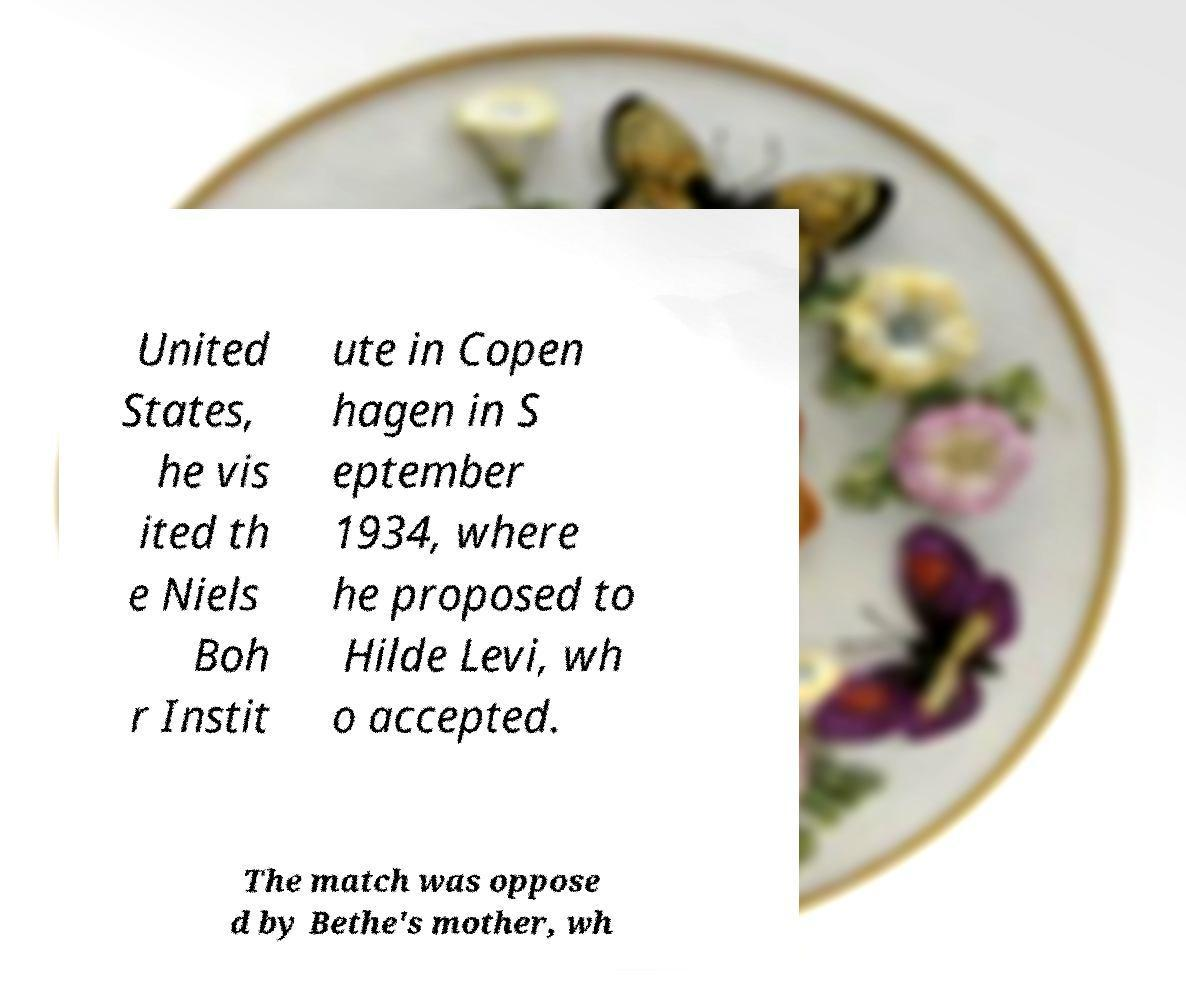Can you read and provide the text displayed in the image?This photo seems to have some interesting text. Can you extract and type it out for me? United States, he vis ited th e Niels Boh r Instit ute in Copen hagen in S eptember 1934, where he proposed to Hilde Levi, wh o accepted. The match was oppose d by Bethe's mother, wh 